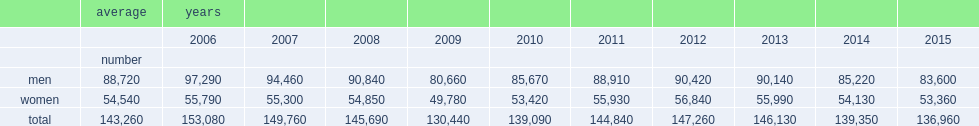Over the 2006-to-2015 period, what was the number of entrants fluctuated? 143260.0. 